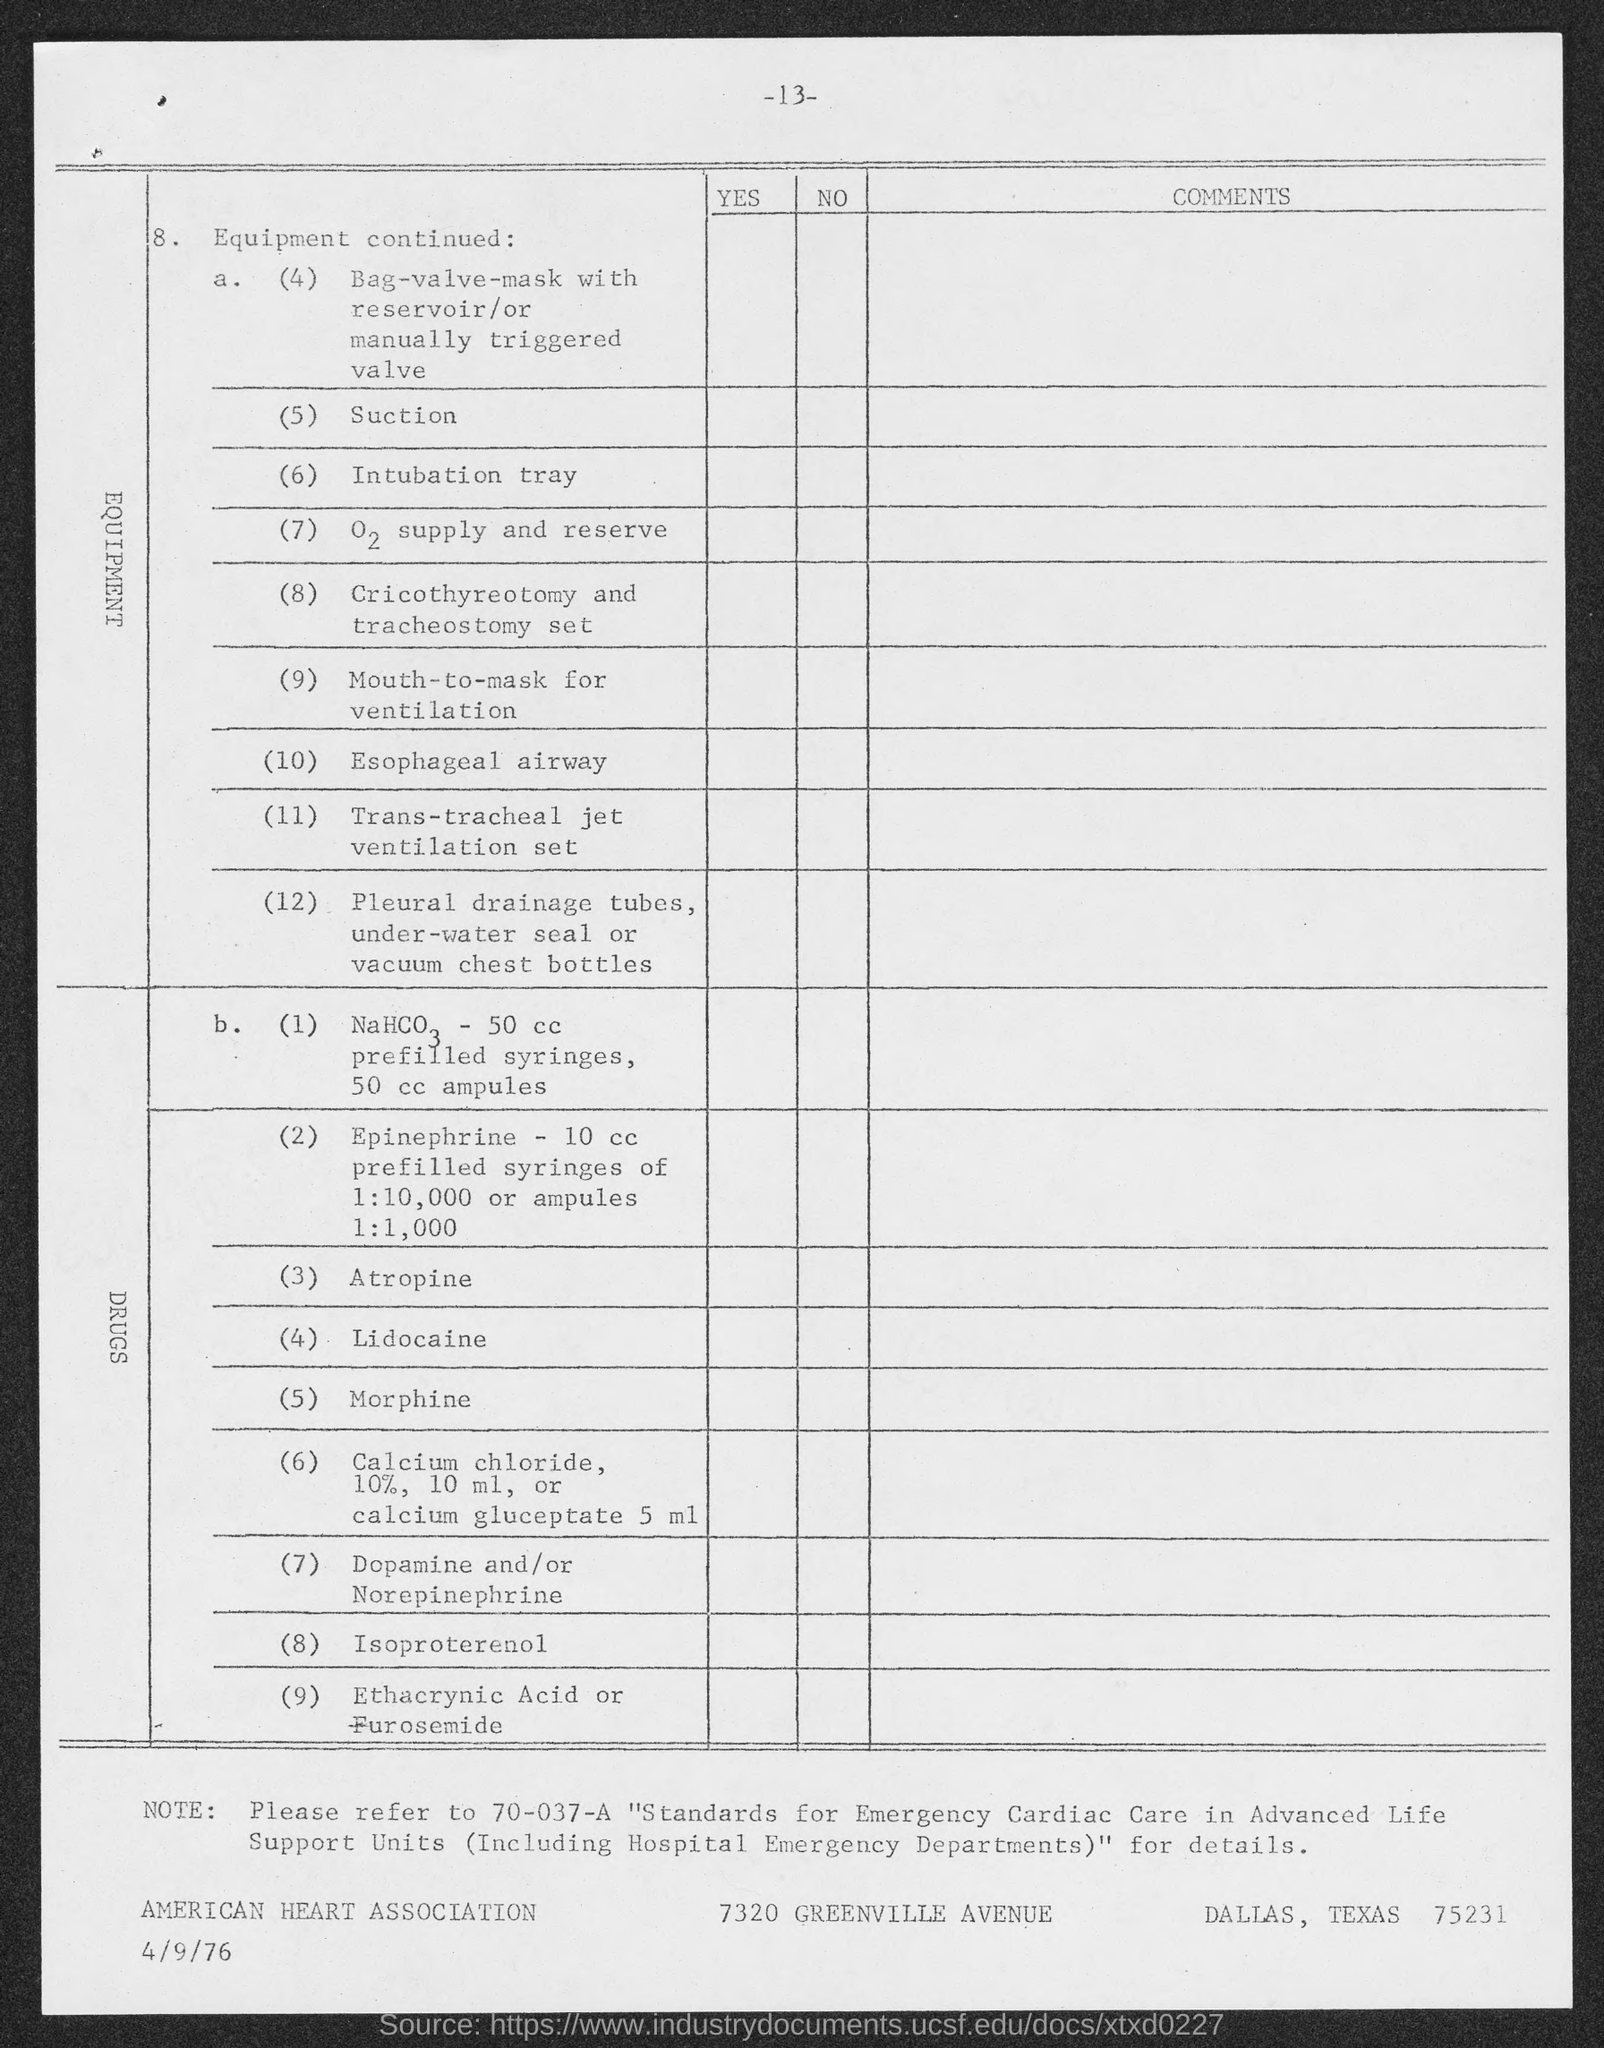Mention a couple of crucial points in this snapshot. The number at the top of the page is -13. 